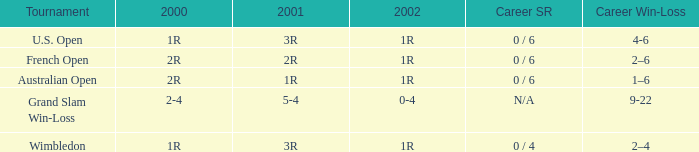Which career win-loss record has a 1r in 2002, a 2r in 2000 and a 2r in 2001? 2–6. 